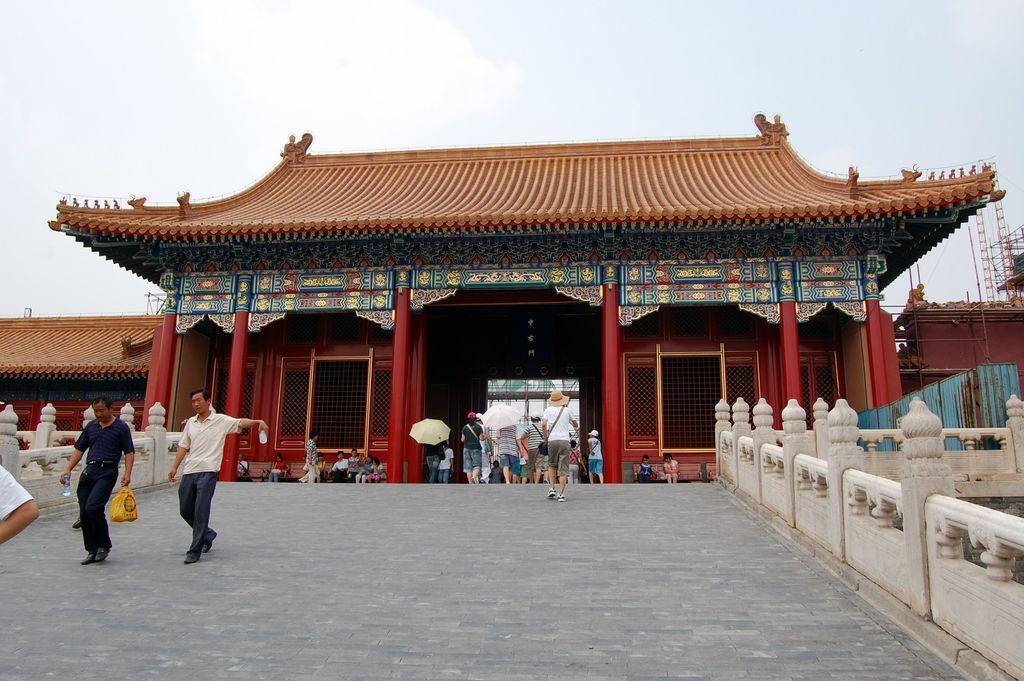How would you summarize this image in a sentence or two? Here I can see a building. In front of this building few people are sitting on the benches and few people are walking on the ground. On the both sides of this image I can see the railing. On the top of the image I can see the sky. 